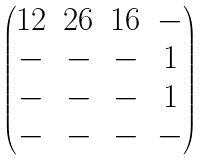<formula> <loc_0><loc_0><loc_500><loc_500>\begin{pmatrix} { 1 2 } & { 2 6 } & { 1 6 } & - \\ - & - & - & { 1 } \\ - & - & - & { 1 } \\ - & - & - & - \end{pmatrix}</formula> 